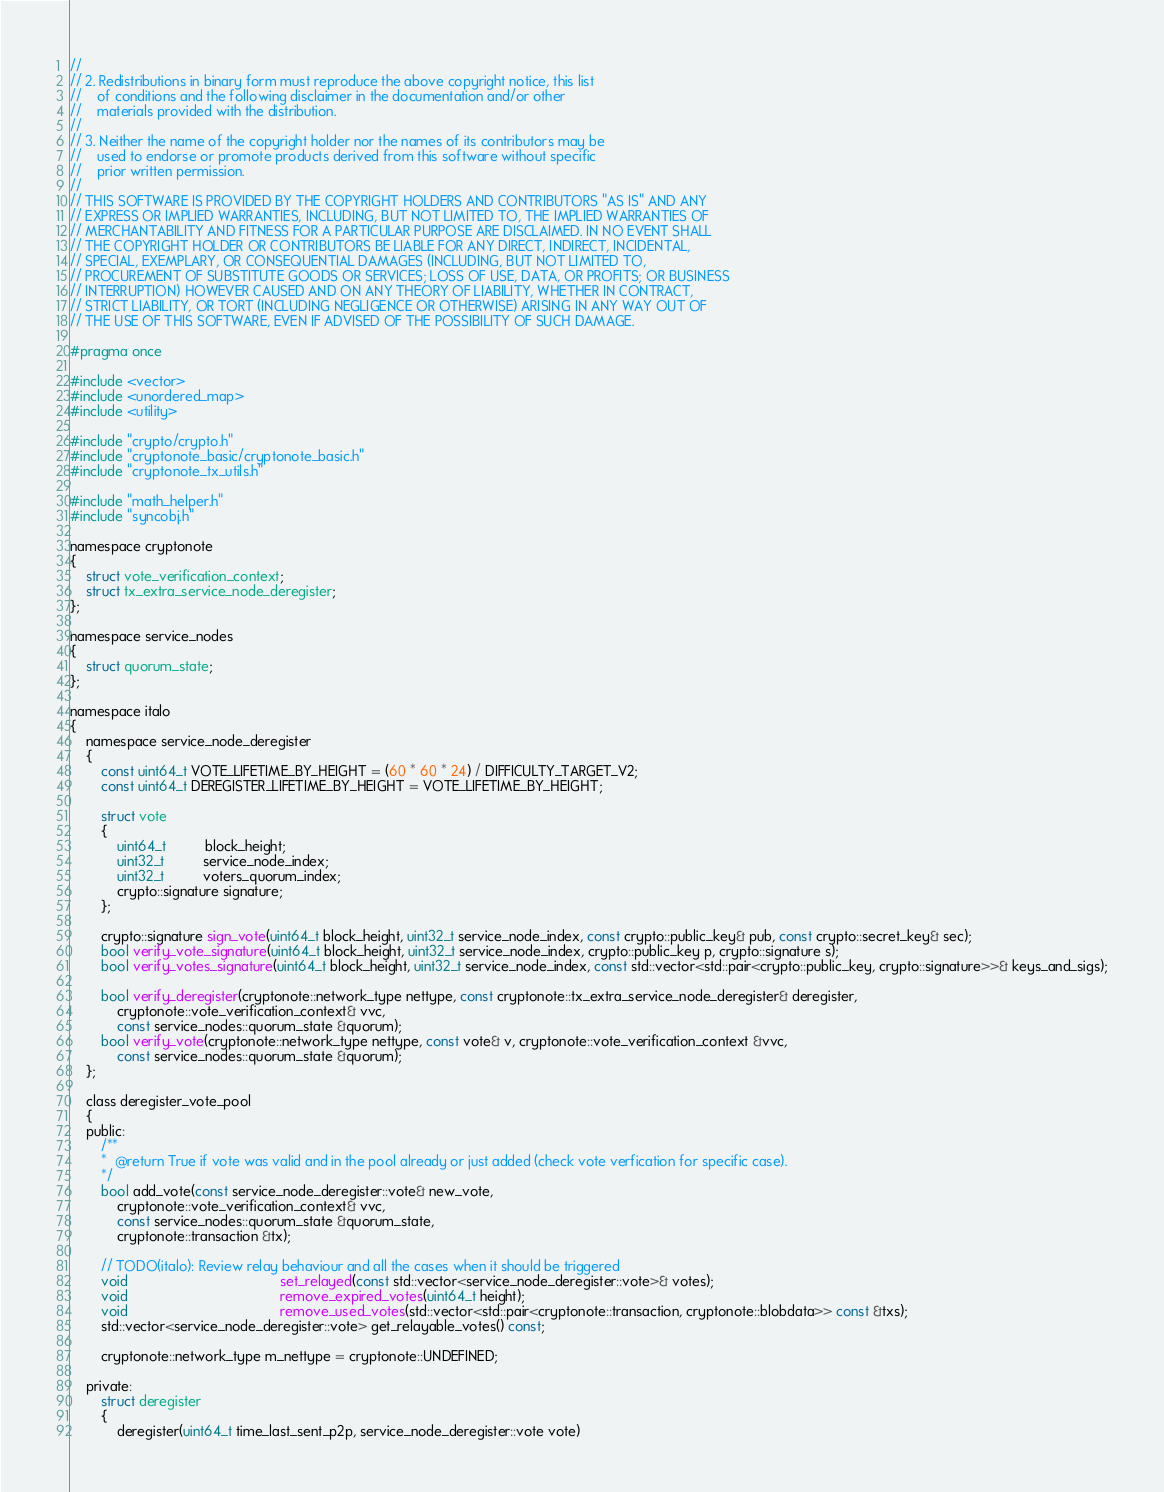<code> <loc_0><loc_0><loc_500><loc_500><_C_>//
// 2. Redistributions in binary form must reproduce the above copyright notice, this list
//    of conditions and the following disclaimer in the documentation and/or other
//    materials provided with the distribution.
//
// 3. Neither the name of the copyright holder nor the names of its contributors may be
//    used to endorse or promote products derived from this software without specific
//    prior written permission.
//
// THIS SOFTWARE IS PROVIDED BY THE COPYRIGHT HOLDERS AND CONTRIBUTORS "AS IS" AND ANY
// EXPRESS OR IMPLIED WARRANTIES, INCLUDING, BUT NOT LIMITED TO, THE IMPLIED WARRANTIES OF
// MERCHANTABILITY AND FITNESS FOR A PARTICULAR PURPOSE ARE DISCLAIMED. IN NO EVENT SHALL
// THE COPYRIGHT HOLDER OR CONTRIBUTORS BE LIABLE FOR ANY DIRECT, INDIRECT, INCIDENTAL,
// SPECIAL, EXEMPLARY, OR CONSEQUENTIAL DAMAGES (INCLUDING, BUT NOT LIMITED TO,
// PROCUREMENT OF SUBSTITUTE GOODS OR SERVICES; LOSS OF USE, DATA, OR PROFITS; OR BUSINESS
// INTERRUPTION) HOWEVER CAUSED AND ON ANY THEORY OF LIABILITY, WHETHER IN CONTRACT,
// STRICT LIABILITY, OR TORT (INCLUDING NEGLIGENCE OR OTHERWISE) ARISING IN ANY WAY OUT OF
// THE USE OF THIS SOFTWARE, EVEN IF ADVISED OF THE POSSIBILITY OF SUCH DAMAGE.

#pragma once

#include <vector>
#include <unordered_map>
#include <utility>

#include "crypto/crypto.h"
#include "cryptonote_basic/cryptonote_basic.h"
#include "cryptonote_tx_utils.h"

#include "math_helper.h"
#include "syncobj.h"

namespace cryptonote
{
	struct vote_verification_context;
	struct tx_extra_service_node_deregister;
};

namespace service_nodes
{
	struct quorum_state;
};

namespace italo
{
	namespace service_node_deregister
	{
		const uint64_t VOTE_LIFETIME_BY_HEIGHT = (60 * 60 * 24) / DIFFICULTY_TARGET_V2;
		const uint64_t DEREGISTER_LIFETIME_BY_HEIGHT = VOTE_LIFETIME_BY_HEIGHT;

		struct vote
		{
			uint64_t          block_height;
			uint32_t          service_node_index;
			uint32_t          voters_quorum_index;
			crypto::signature signature;
		};

		crypto::signature sign_vote(uint64_t block_height, uint32_t service_node_index, const crypto::public_key& pub, const crypto::secret_key& sec);
		bool verify_vote_signature(uint64_t block_height, uint32_t service_node_index, crypto::public_key p, crypto::signature s);
		bool verify_votes_signature(uint64_t block_height, uint32_t service_node_index, const std::vector<std::pair<crypto::public_key, crypto::signature>>& keys_and_sigs);

		bool verify_deregister(cryptonote::network_type nettype, const cryptonote::tx_extra_service_node_deregister& deregister,
			cryptonote::vote_verification_context& vvc,
			const service_nodes::quorum_state &quorum);
		bool verify_vote(cryptonote::network_type nettype, const vote& v, cryptonote::vote_verification_context &vvc,
			const service_nodes::quorum_state &quorum);
	};

	class deregister_vote_pool
	{
	public:
		/**
		*  @return True if vote was valid and in the pool already or just added (check vote verfication for specific case).
		*/
		bool add_vote(const service_node_deregister::vote& new_vote,
			cryptonote::vote_verification_context& vvc,
			const service_nodes::quorum_state &quorum_state,
			cryptonote::transaction &tx);

		// TODO(italo): Review relay behaviour and all the cases when it should be triggered
		void                                       set_relayed(const std::vector<service_node_deregister::vote>& votes);
		void                                       remove_expired_votes(uint64_t height);
		void                                       remove_used_votes(std::vector<std::pair<cryptonote::transaction, cryptonote::blobdata>> const &txs);
		std::vector<service_node_deregister::vote> get_relayable_votes() const;

		cryptonote::network_type m_nettype = cryptonote::UNDEFINED;

	private:
		struct deregister
		{
			deregister(uint64_t time_last_sent_p2p, service_node_deregister::vote vote)</code> 